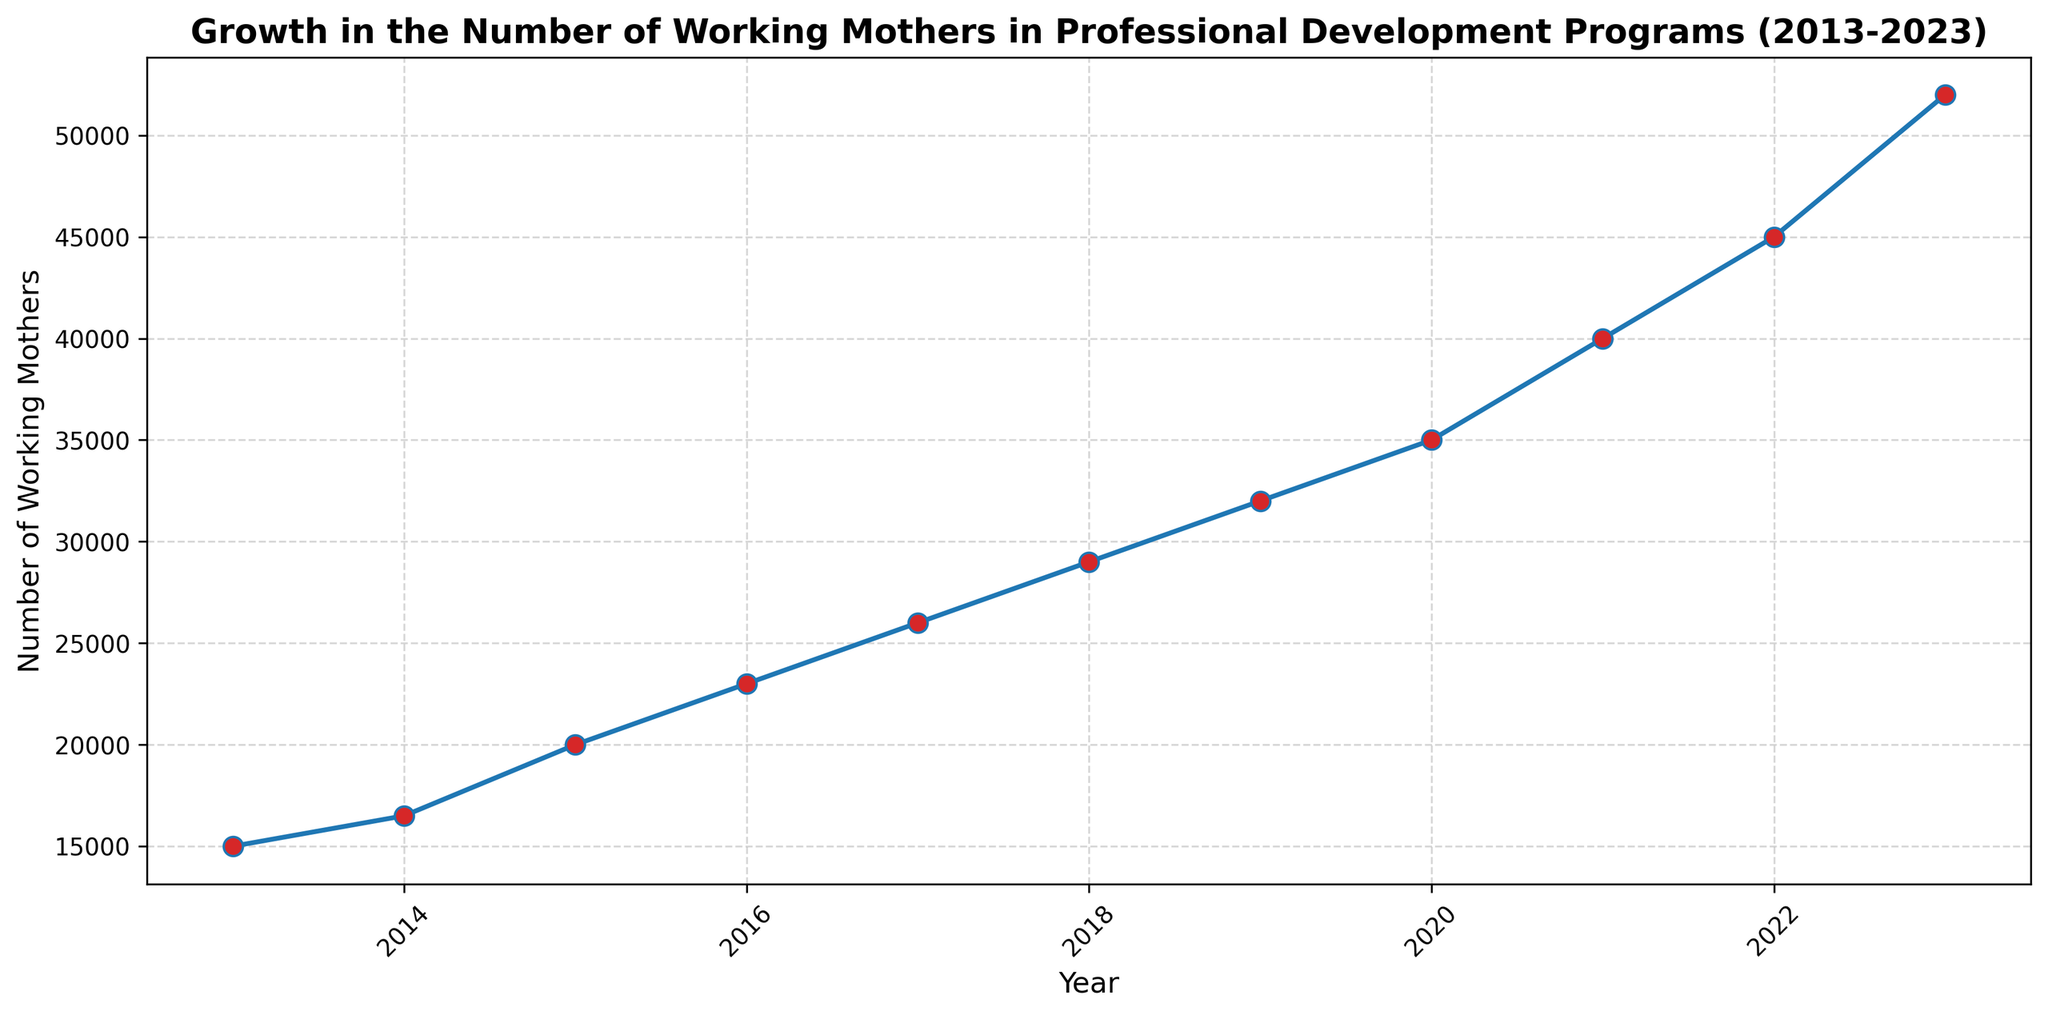What is the number of working mothers participating in professional development programs in 2015? Look at the data point corresponding to the year 2015. It shows the number of working mothers in professional development programs during that year.
Answer: 20000 In which year did the number of working mothers in professional development programs first reach 35000? Find the year where the number of working mothers first equals 35000 by looking at the plotted line on the chart.
Answer: 2020 What is the difference in the number of working mothers participating in professional development programs between 2018 and 2023? Identify the data points for 2018 and 2023, subtract the number for 2018 from the number for 2023: (52000 - 29000).
Answer: 23000 What is the average number of working mothers in professional development programs from 2013 to 2017? Sum the numbers from 2013 to 2017 and divide by the number of years. (15000 + 16500 + 20000 + 23000 + 26000) / 5 = 100500 / 5
Answer: 20100 How many more working mothers participated in professional development programs in 2023 compared to 2013? Subtract the number of working mothers in 2013 from the number in 2023: 52000 - 15000.
Answer: 37000 How does the average growth per year from 2013 to 2023 compare to the average growth per year from 2013 to 2018? Calculate the total growth and divide by the number of years for both periods. From 2013 to 2023: (52000 - 15000)/10 = 3700; From 2013 to 2018: (29000 - 15000)/5 = 2800. Compare the two averages.
Answer: 3700 > 2800 In which year did the number of working mothers in professional development programs exceed 30000 for the first time? Find the first year where the number of working mothers is greater than 30000 by reviewing the plotted data points.
Answer: 2019 What is the percentage increase in the number of working mothers in professional development programs from 2019 to 2023? Calculate the percentage increase using the formula [(52000 - 32000) / 32000] * 100.
Answer: 62.5% Which year saw the highest growth in the number of working mothers in professional development programs compared to the previous year? Check each yearly increment and find the one with the highest value. The increments are: 1500 (2013-2014), 3500 (2014-2015), 3000 (2015-2016), 3000 (2016-2017), 3000 (2017-2018), 3000 (2018-2019), 3000 (2019-2020), 5000 (2020-2021), 5000 (2021-2022), 7000 (2022-2023). The highest increment is 7000 for 2022-2023.
Answer: 2022-2023 What visual element distinguishes the data points on the plotted line? Observe the color and style of the markers used for the data points along the plotted line.
Answer: Red markers 